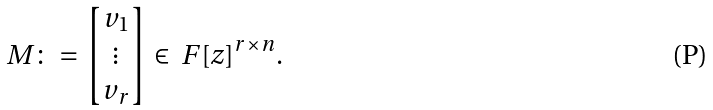Convert formula to latex. <formula><loc_0><loc_0><loc_500><loc_500>M \colon = \begin{bmatrix} v _ { 1 } \\ \vdots \\ v _ { r } \end{bmatrix} \in \ F [ z ] ^ { r \times n } .</formula> 